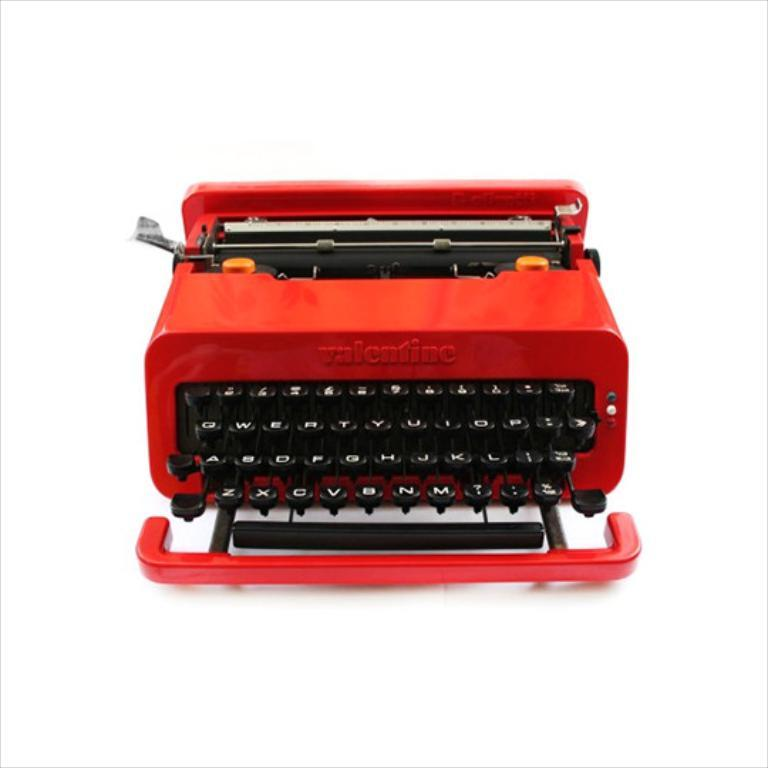Provide a one-sentence caption for the provided image. A red Valentine typewriter against a white back drop. 